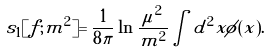Convert formula to latex. <formula><loc_0><loc_0><loc_500><loc_500>s _ { 1 } [ f ; m ^ { 2 } ] = \frac { 1 } { 8 \pi } \ln \frac { \mu ^ { 2 } } { m ^ { 2 } } \int d ^ { 2 } x \phi ( x ) .</formula> 